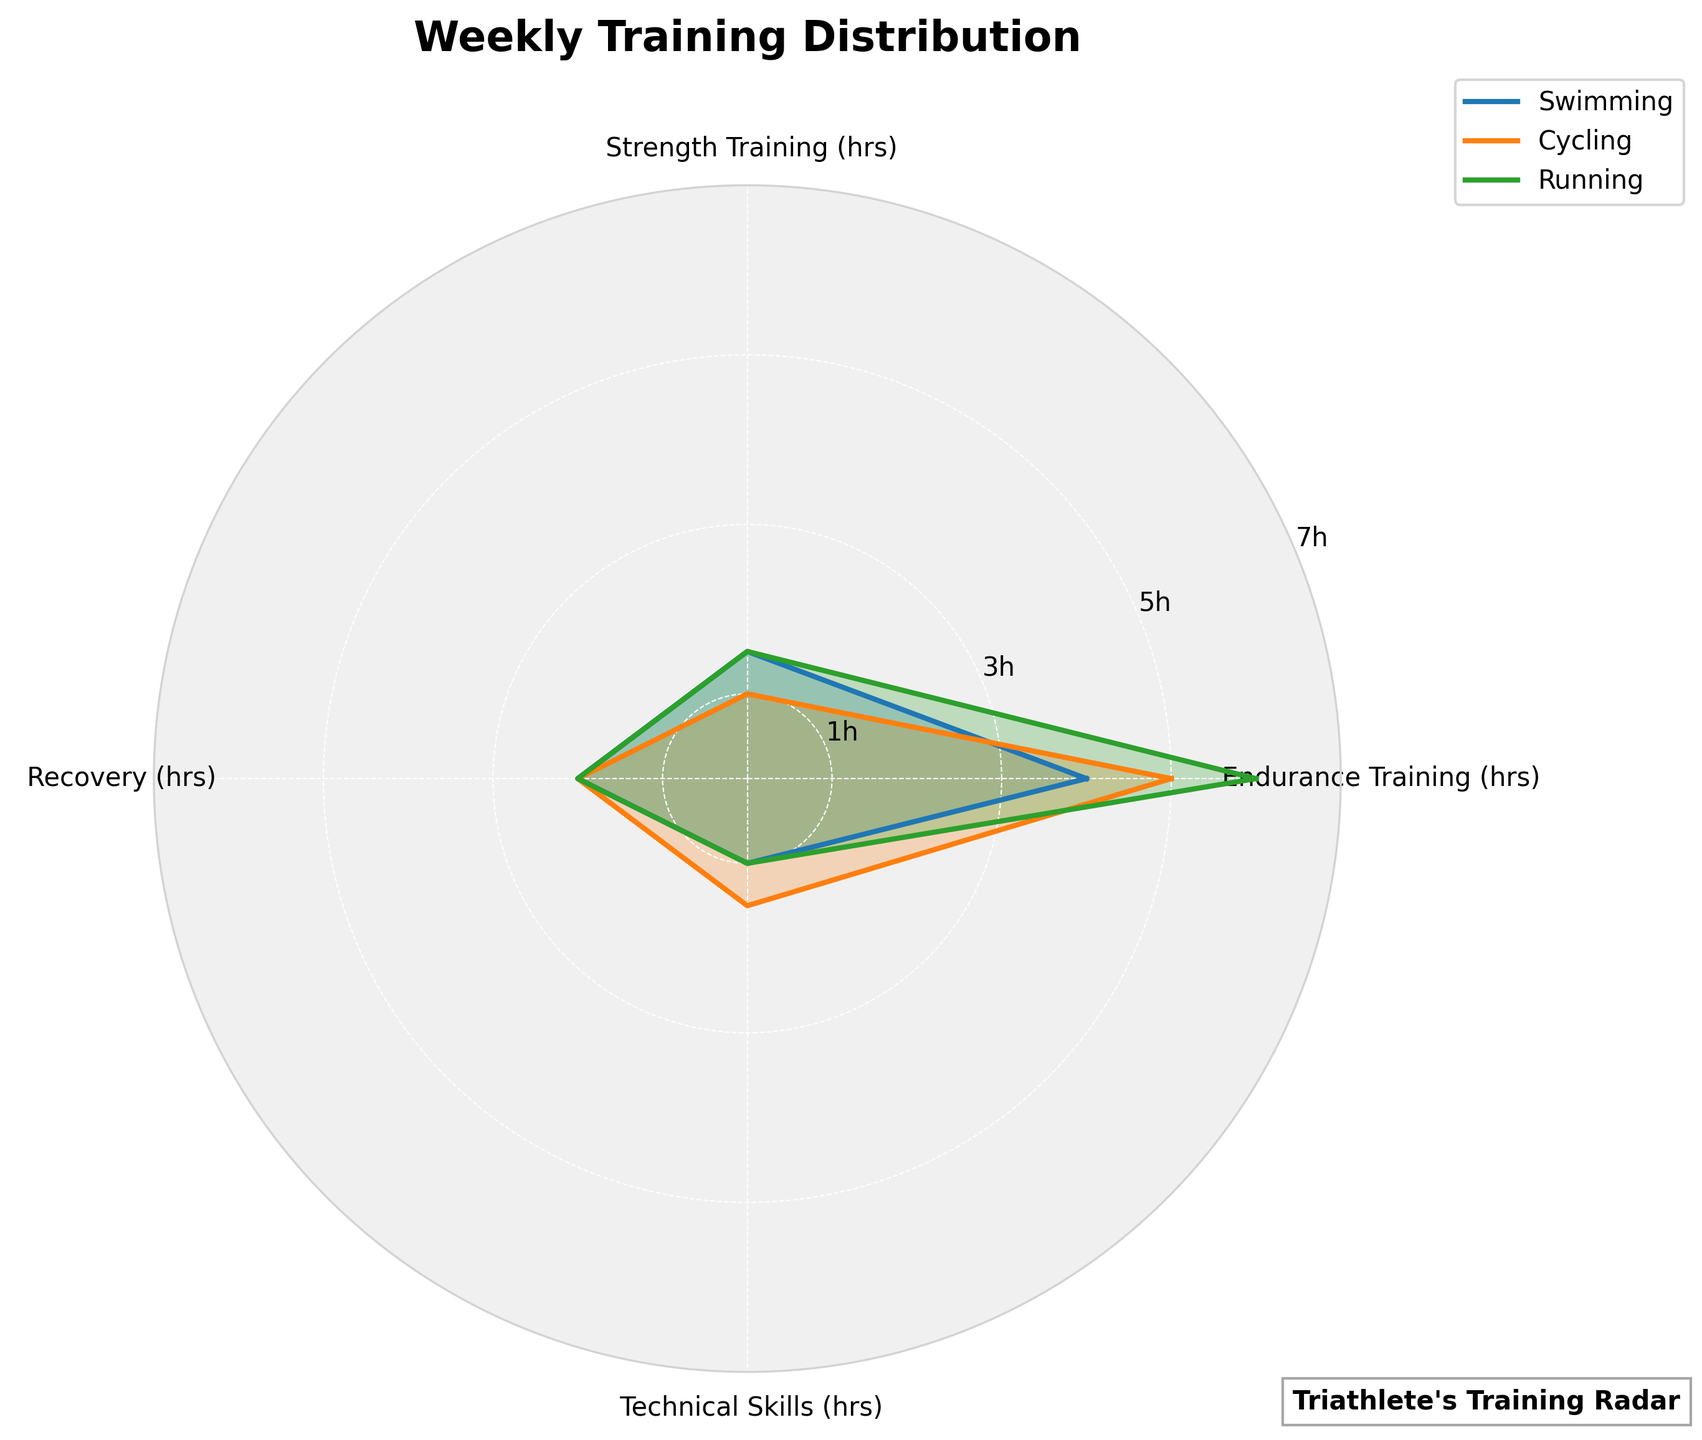What's the title of the figure? The radar chart has a title displayed at the top of the figure, which provides a context for the data being visualized.
Answer: Weekly Training Distribution What does the technical skills training time for cycling look like? Look at the section labeled "Cycling" and find the value corresponding to "Technical Skills." It should be marked by the data point along the axis labeled "Technical Skills."
Answer: 1.5 hours How many categories are plotted? Count the number of different categories (Swimming, Cycling, Running) shown in the legend or around the radar chart.
Answer: 3 Which category has the highest value for endurance training? Compare the values for "Endurance Training" across all three categories (Swimming, Cycling, Running). The highest value will be the one that extends the furthest from the center.
Answer: Running What's the difference in strength training hours between swimming and running? Subtract the strength training value of running (1.5 hours) from the strength training value of swimming (1.5 hours).
Answer: 0 hours What's the total training hours for cycling? Sum the hours for all training types (Endurance, Strength, Recovery, Technical Skills) for cycling.
Answer: 9.5 hours Does any category devote more than twice the amount of time to endurance training compared to recovery? Check the endurance and recovery training hours for each category. For "Swimming" (4, 2), "Cycling" (5, 2), "Running" (6, 2), none exceed twice the duration.
Answer: No Which category shows the least amount of time devoted to technical skills? Compare the technical skills training hours across categories and find the smallest value. Both "Swimming" and "Running" have 1 hour, which is the least.
Answer: Swimming and Running How does the recovery time for swimming compare to the recovery time for running? Look at the values for recovery training for both swimming and running and compare them. They are equal (2 hours each).
Answer: Equal How do the training distributions for swimming and cycling compare overall? Evaluate all four training types for both swimming and cycling. Swimming: (4, 1.5, 2, 1); Cycling: (5, 1, 2, 1.5). Cycling has more endurance and technical training, while swimming has marginally more strength training. Recovery time is equal.
Answer: Cycling has more endurance and technical, but less strength 